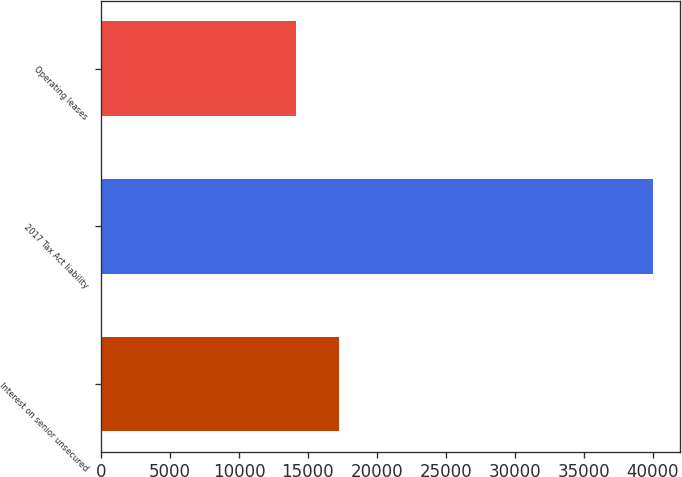Convert chart to OTSL. <chart><loc_0><loc_0><loc_500><loc_500><bar_chart><fcel>Interest on senior unsecured<fcel>2017 Tax Act liability<fcel>Operating leases<nl><fcel>17268<fcel>40000<fcel>14122<nl></chart> 